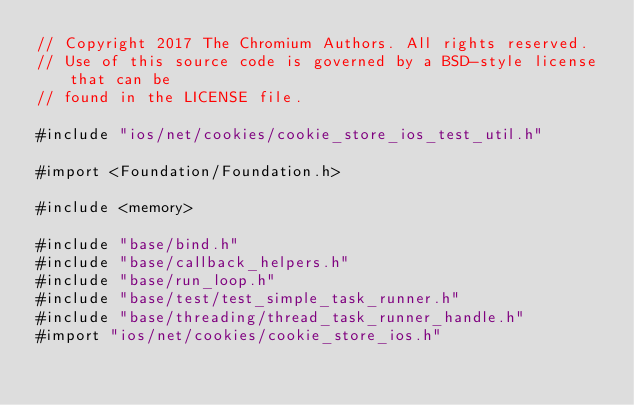<code> <loc_0><loc_0><loc_500><loc_500><_ObjectiveC_>// Copyright 2017 The Chromium Authors. All rights reserved.
// Use of this source code is governed by a BSD-style license that can be
// found in the LICENSE file.

#include "ios/net/cookies/cookie_store_ios_test_util.h"

#import <Foundation/Foundation.h>

#include <memory>

#include "base/bind.h"
#include "base/callback_helpers.h"
#include "base/run_loop.h"
#include "base/test/test_simple_task_runner.h"
#include "base/threading/thread_task_runner_handle.h"
#import "ios/net/cookies/cookie_store_ios.h"</code> 